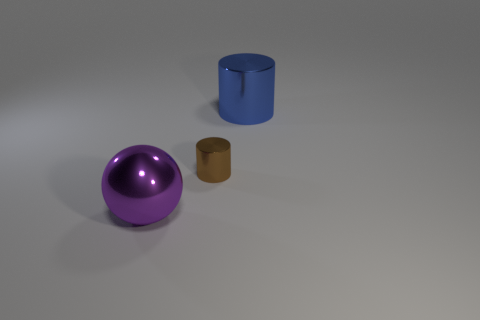Add 1 small metal cylinders. How many objects exist? 4 Subtract all cylinders. How many objects are left? 1 Subtract all brown shiny objects. Subtract all large metallic things. How many objects are left? 0 Add 2 brown metal cylinders. How many brown metal cylinders are left? 3 Add 3 big metallic things. How many big metallic things exist? 5 Subtract 0 purple blocks. How many objects are left? 3 